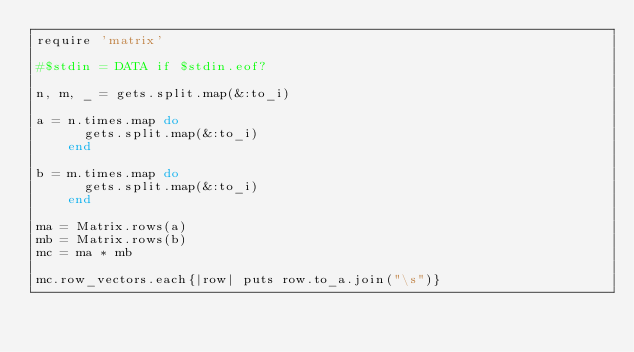<code> <loc_0><loc_0><loc_500><loc_500><_Ruby_>require 'matrix'

#$stdin = DATA if $stdin.eof?

n, m, _ = gets.split.map(&:to_i)

a = n.times.map do
      gets.split.map(&:to_i)
    end

b = m.times.map do
      gets.split.map(&:to_i)
    end

ma = Matrix.rows(a)
mb = Matrix.rows(b)
mc = ma * mb

mc.row_vectors.each{|row| puts row.to_a.join("\s")}
</code> 